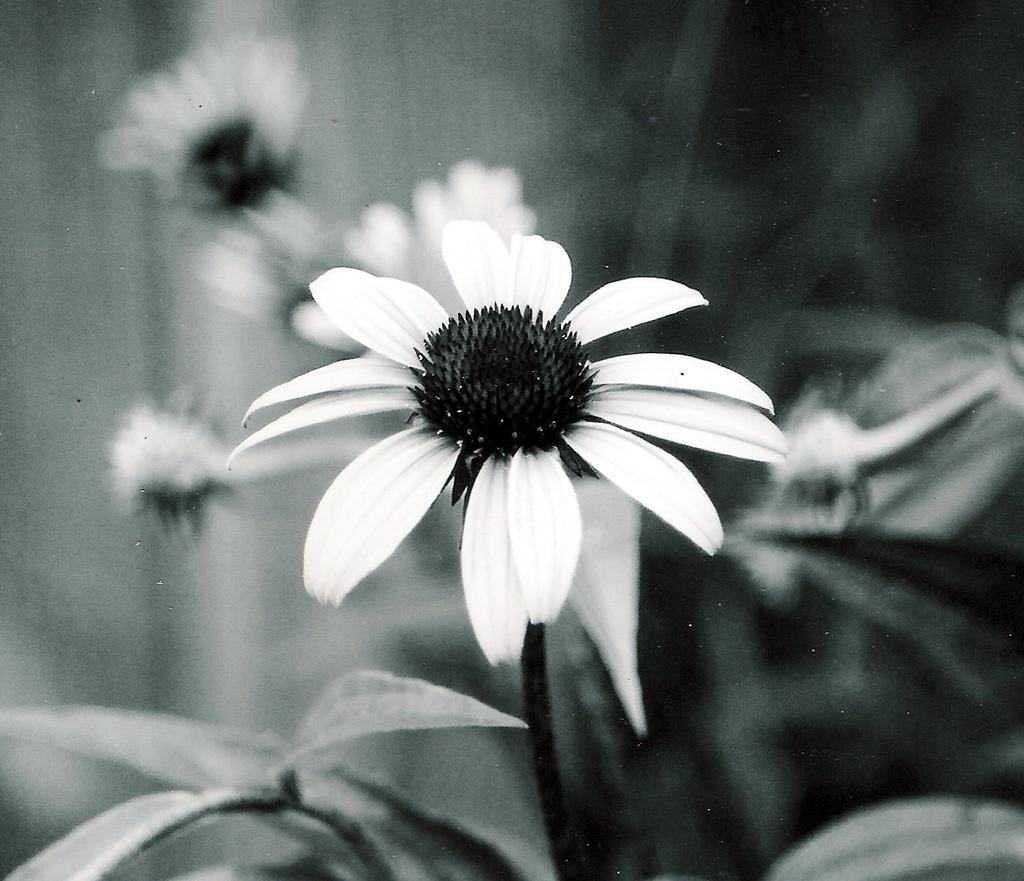What is the color scheme of the image? The image is black and white. What type of plant can be seen in the image? There is a flower in the image. What other parts of the plant are visible? There are leaves and a stem in the image. How would you describe the background of the image? The background of the image is blurry. What type of pet is shown in the image? There is no pet present in the image; it features a flower with leaves and a stem. What is the tendency of the flower to offer its services in the image? The image does not depict a flower offering any services, as it is a still image of a flower with leaves and a stem. 